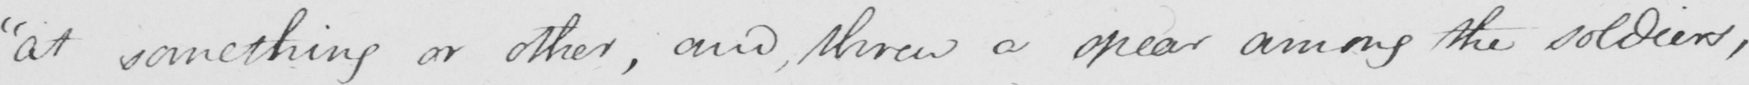Please transcribe the handwritten text in this image. " at something or other , and , threw a spear among the soldiers , 